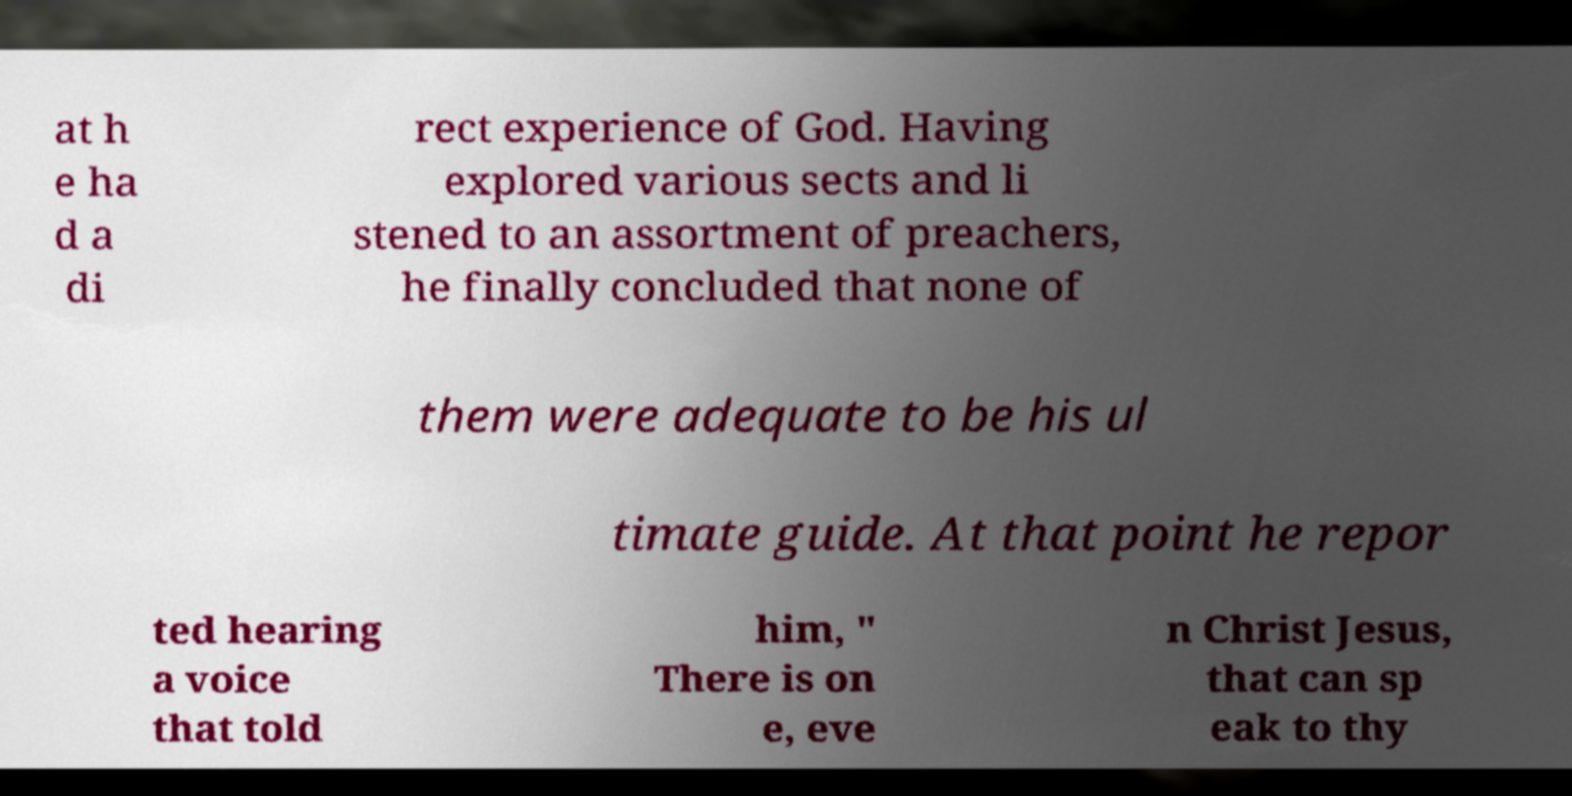Can you read and provide the text displayed in the image?This photo seems to have some interesting text. Can you extract and type it out for me? at h e ha d a di rect experience of God. Having explored various sects and li stened to an assortment of preachers, he finally concluded that none of them were adequate to be his ul timate guide. At that point he repor ted hearing a voice that told him, " There is on e, eve n Christ Jesus, that can sp eak to thy 